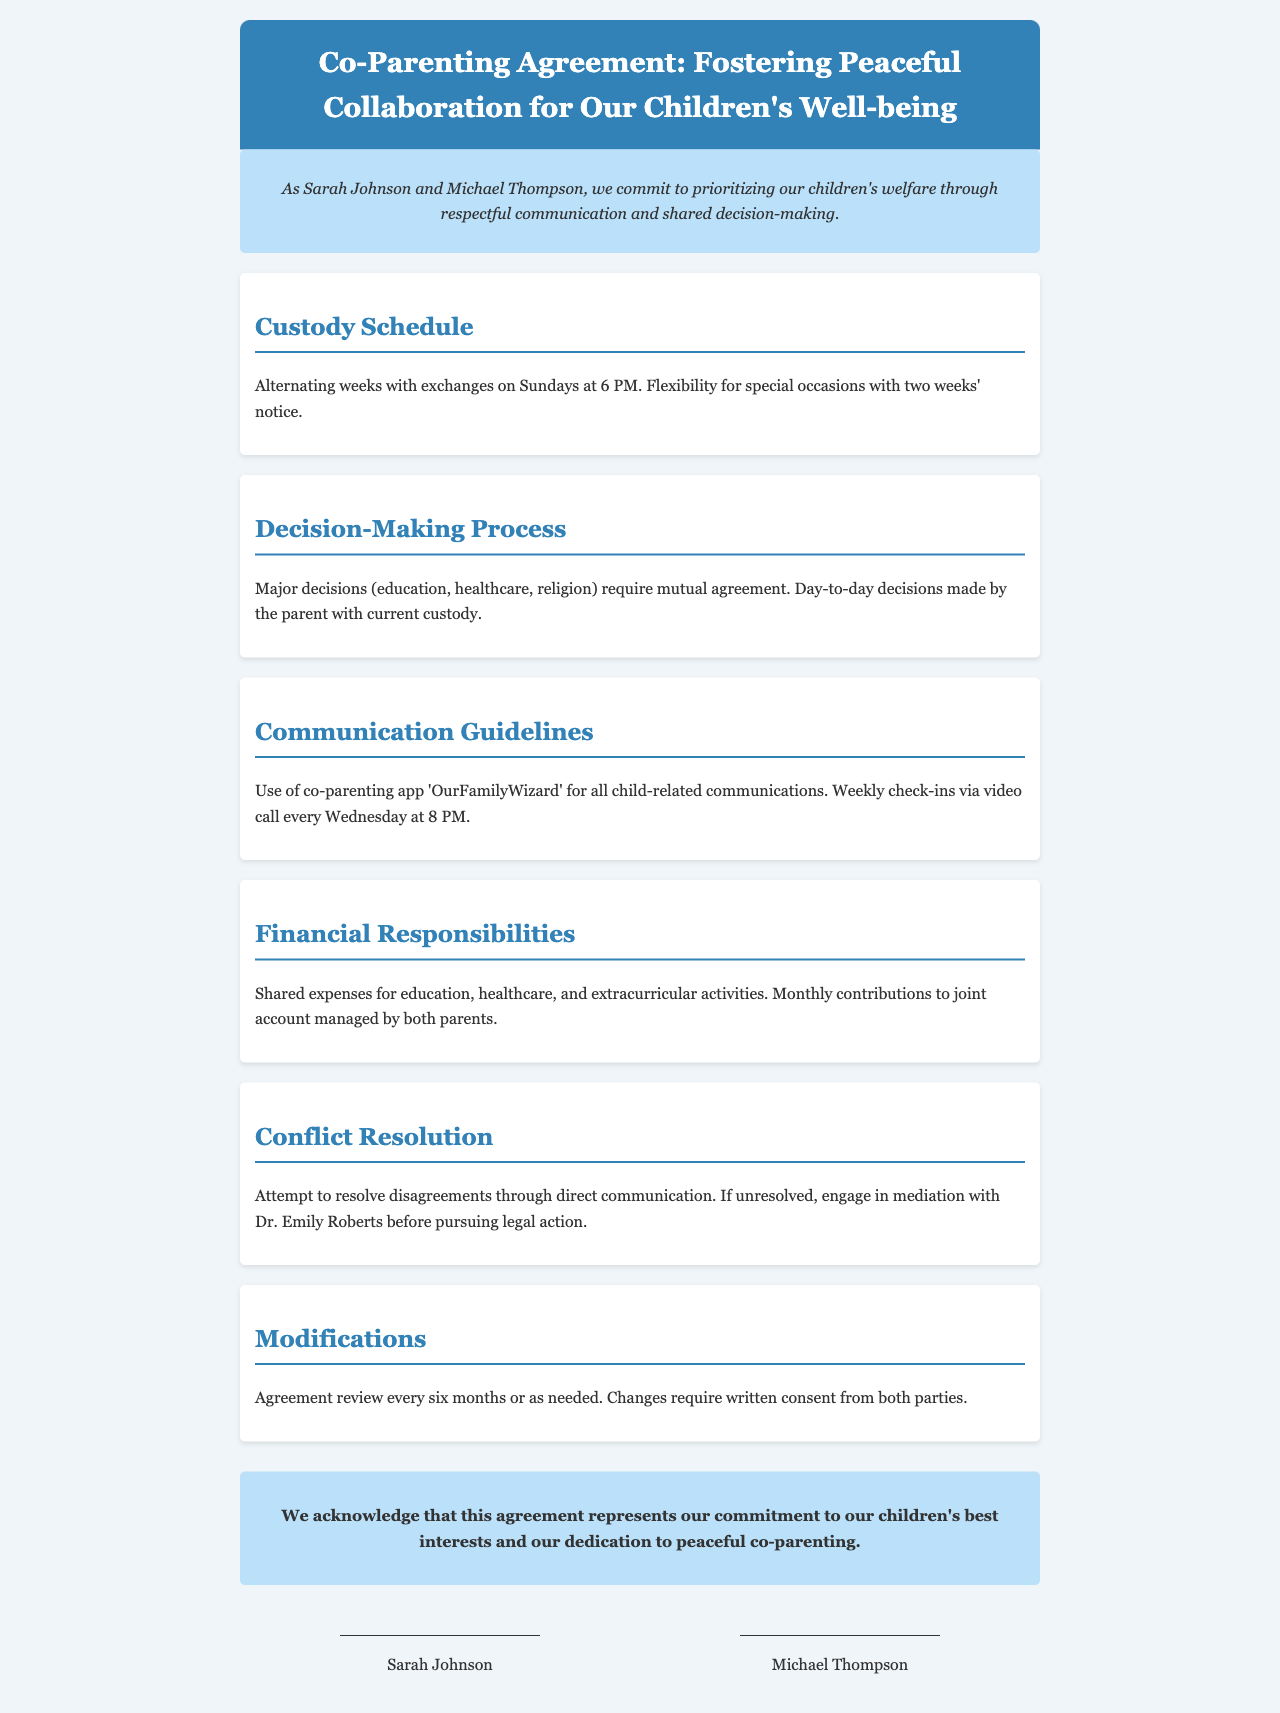What is the custody schedule? The custody schedule outlines how the parents will share custody time, specifically mentioning the alternating weeks and exchange timings.
Answer: Alternating weeks with exchanges on Sundays at 6 PM What is required for major decisions? This question seeks to identify the conditions under which major decisions regarding the child are made according to the document.
Answer: Mutual agreement What app is used for communication? This addresses the specific tool mentioned for co-parent communication in the document.
Answer: OurFamilyWizard What should parents do if they can't resolve a disagreement? This question looks for the process prescribed for conflict resolution when direct communication fails.
Answer: Engage in mediation When is the agreement reviewed? The question asks about the frequency at which the co-parenting agreement is assessed and potentially modified.
Answer: Every six months 